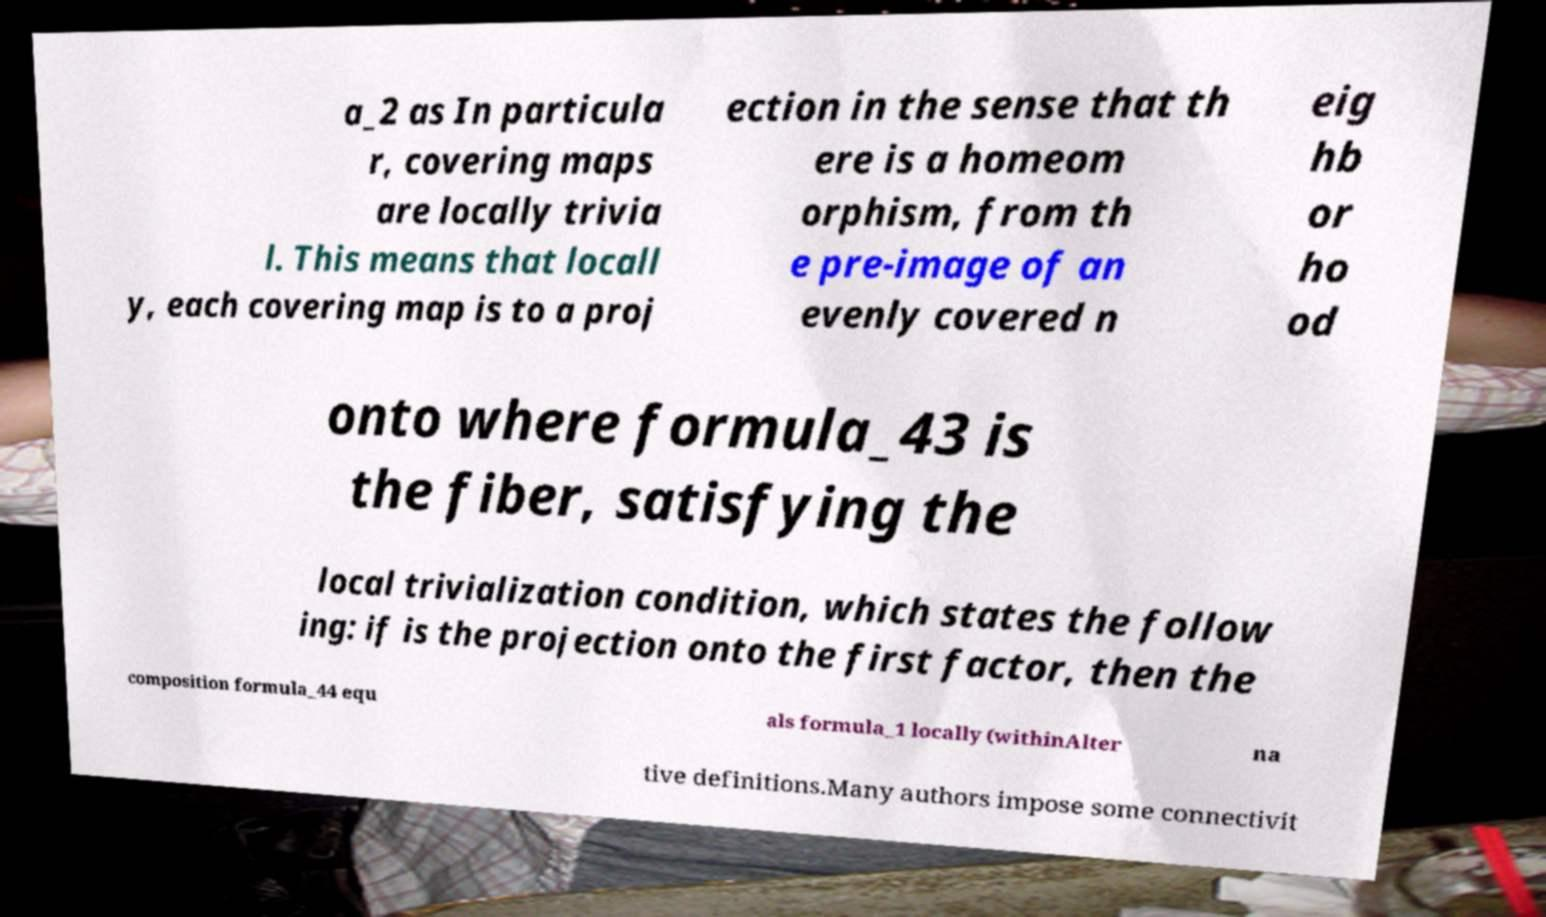Can you read and provide the text displayed in the image?This photo seems to have some interesting text. Can you extract and type it out for me? a_2 as In particula r, covering maps are locally trivia l. This means that locall y, each covering map is to a proj ection in the sense that th ere is a homeom orphism, from th e pre-image of an evenly covered n eig hb or ho od onto where formula_43 is the fiber, satisfying the local trivialization condition, which states the follow ing: if is the projection onto the first factor, then the composition formula_44 equ als formula_1 locally (withinAlter na tive definitions.Many authors impose some connectivit 